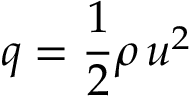Convert formula to latex. <formula><loc_0><loc_0><loc_500><loc_500>q = { \frac { 1 } { 2 } } \rho \, u ^ { 2 }</formula> 